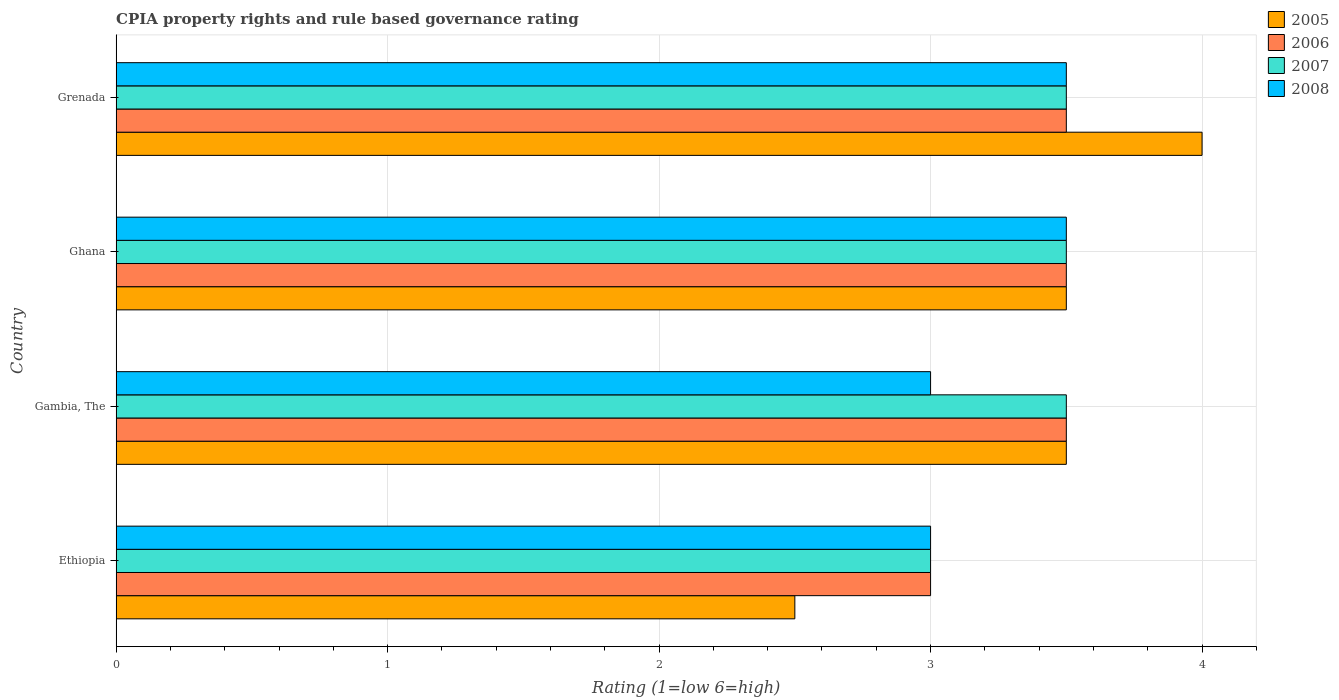How many different coloured bars are there?
Offer a very short reply. 4. How many groups of bars are there?
Provide a short and direct response. 4. Are the number of bars per tick equal to the number of legend labels?
Your answer should be compact. Yes. How many bars are there on the 4th tick from the bottom?
Make the answer very short. 4. What is the label of the 2nd group of bars from the top?
Your answer should be very brief. Ghana. What is the CPIA rating in 2006 in Ethiopia?
Your answer should be compact. 3. Across all countries, what is the maximum CPIA rating in 2005?
Give a very brief answer. 4. In which country was the CPIA rating in 2006 maximum?
Your response must be concise. Gambia, The. In which country was the CPIA rating in 2005 minimum?
Make the answer very short. Ethiopia. What is the average CPIA rating in 2007 per country?
Provide a short and direct response. 3.38. What is the difference between the CPIA rating in 2007 and CPIA rating in 2006 in Ghana?
Ensure brevity in your answer.  0. In how many countries, is the CPIA rating in 2008 greater than 0.4 ?
Provide a succinct answer. 4. Is the CPIA rating in 2008 in Gambia, The less than that in Ghana?
Keep it short and to the point. Yes. Is the difference between the CPIA rating in 2007 in Ethiopia and Ghana greater than the difference between the CPIA rating in 2006 in Ethiopia and Ghana?
Provide a short and direct response. No. What is the difference between the highest and the lowest CPIA rating in 2006?
Make the answer very short. 0.5. Is the sum of the CPIA rating in 2007 in Ghana and Grenada greater than the maximum CPIA rating in 2008 across all countries?
Keep it short and to the point. Yes. What does the 1st bar from the top in Ethiopia represents?
Your response must be concise. 2008. How many bars are there?
Offer a very short reply. 16. Are all the bars in the graph horizontal?
Your response must be concise. Yes. How many countries are there in the graph?
Ensure brevity in your answer.  4. Where does the legend appear in the graph?
Your response must be concise. Top right. How are the legend labels stacked?
Make the answer very short. Vertical. What is the title of the graph?
Keep it short and to the point. CPIA property rights and rule based governance rating. What is the Rating (1=low 6=high) in 2006 in Ethiopia?
Provide a short and direct response. 3. What is the Rating (1=low 6=high) of 2005 in Gambia, The?
Make the answer very short. 3.5. What is the Rating (1=low 6=high) in 2006 in Gambia, The?
Keep it short and to the point. 3.5. What is the Rating (1=low 6=high) in 2007 in Gambia, The?
Give a very brief answer. 3.5. What is the Rating (1=low 6=high) in 2005 in Ghana?
Your response must be concise. 3.5. What is the Rating (1=low 6=high) of 2007 in Ghana?
Provide a short and direct response. 3.5. What is the Rating (1=low 6=high) in 2005 in Grenada?
Offer a terse response. 4. What is the Rating (1=low 6=high) in 2006 in Grenada?
Make the answer very short. 3.5. What is the Rating (1=low 6=high) in 2007 in Grenada?
Offer a very short reply. 3.5. What is the Rating (1=low 6=high) in 2008 in Grenada?
Provide a succinct answer. 3.5. Across all countries, what is the maximum Rating (1=low 6=high) in 2007?
Ensure brevity in your answer.  3.5. Across all countries, what is the minimum Rating (1=low 6=high) of 2005?
Your response must be concise. 2.5. Across all countries, what is the minimum Rating (1=low 6=high) in 2006?
Keep it short and to the point. 3. Across all countries, what is the minimum Rating (1=low 6=high) of 2007?
Ensure brevity in your answer.  3. What is the total Rating (1=low 6=high) in 2005 in the graph?
Make the answer very short. 13.5. What is the total Rating (1=low 6=high) of 2006 in the graph?
Your answer should be very brief. 13.5. What is the total Rating (1=low 6=high) in 2008 in the graph?
Offer a very short reply. 13. What is the difference between the Rating (1=low 6=high) of 2006 in Ethiopia and that in Ghana?
Your answer should be very brief. -0.5. What is the difference between the Rating (1=low 6=high) of 2005 in Ethiopia and that in Grenada?
Give a very brief answer. -1.5. What is the difference between the Rating (1=low 6=high) of 2006 in Ethiopia and that in Grenada?
Provide a succinct answer. -0.5. What is the difference between the Rating (1=low 6=high) in 2007 in Ethiopia and that in Grenada?
Provide a succinct answer. -0.5. What is the difference between the Rating (1=low 6=high) in 2008 in Ethiopia and that in Grenada?
Ensure brevity in your answer.  -0.5. What is the difference between the Rating (1=low 6=high) of 2005 in Gambia, The and that in Ghana?
Provide a short and direct response. 0. What is the difference between the Rating (1=low 6=high) in 2008 in Gambia, The and that in Ghana?
Your response must be concise. -0.5. What is the difference between the Rating (1=low 6=high) in 2006 in Gambia, The and that in Grenada?
Give a very brief answer. 0. What is the difference between the Rating (1=low 6=high) in 2008 in Gambia, The and that in Grenada?
Your answer should be compact. -0.5. What is the difference between the Rating (1=low 6=high) in 2007 in Ghana and that in Grenada?
Provide a succinct answer. 0. What is the difference between the Rating (1=low 6=high) of 2005 in Ethiopia and the Rating (1=low 6=high) of 2008 in Gambia, The?
Keep it short and to the point. -0.5. What is the difference between the Rating (1=low 6=high) in 2006 in Ethiopia and the Rating (1=low 6=high) in 2007 in Gambia, The?
Make the answer very short. -0.5. What is the difference between the Rating (1=low 6=high) in 2006 in Ethiopia and the Rating (1=low 6=high) in 2008 in Gambia, The?
Your response must be concise. 0. What is the difference between the Rating (1=low 6=high) of 2007 in Ethiopia and the Rating (1=low 6=high) of 2008 in Gambia, The?
Keep it short and to the point. 0. What is the difference between the Rating (1=low 6=high) in 2005 in Ethiopia and the Rating (1=low 6=high) in 2007 in Ghana?
Provide a succinct answer. -1. What is the difference between the Rating (1=low 6=high) of 2006 in Ethiopia and the Rating (1=low 6=high) of 2007 in Ghana?
Provide a short and direct response. -0.5. What is the difference between the Rating (1=low 6=high) of 2006 in Ethiopia and the Rating (1=low 6=high) of 2008 in Ghana?
Your response must be concise. -0.5. What is the difference between the Rating (1=low 6=high) of 2005 in Ethiopia and the Rating (1=low 6=high) of 2006 in Grenada?
Offer a very short reply. -1. What is the difference between the Rating (1=low 6=high) in 2006 in Ethiopia and the Rating (1=low 6=high) in 2008 in Grenada?
Give a very brief answer. -0.5. What is the difference between the Rating (1=low 6=high) in 2007 in Ethiopia and the Rating (1=low 6=high) in 2008 in Grenada?
Your response must be concise. -0.5. What is the difference between the Rating (1=low 6=high) of 2005 in Gambia, The and the Rating (1=low 6=high) of 2008 in Ghana?
Your response must be concise. 0. What is the difference between the Rating (1=low 6=high) of 2006 in Gambia, The and the Rating (1=low 6=high) of 2007 in Ghana?
Make the answer very short. 0. What is the difference between the Rating (1=low 6=high) of 2007 in Gambia, The and the Rating (1=low 6=high) of 2008 in Ghana?
Give a very brief answer. 0. What is the difference between the Rating (1=low 6=high) of 2005 in Gambia, The and the Rating (1=low 6=high) of 2006 in Grenada?
Provide a short and direct response. 0. What is the difference between the Rating (1=low 6=high) in 2005 in Gambia, The and the Rating (1=low 6=high) in 2007 in Grenada?
Your answer should be compact. 0. What is the difference between the Rating (1=low 6=high) in 2006 in Gambia, The and the Rating (1=low 6=high) in 2008 in Grenada?
Your answer should be compact. 0. What is the difference between the Rating (1=low 6=high) in 2007 in Gambia, The and the Rating (1=low 6=high) in 2008 in Grenada?
Keep it short and to the point. 0. What is the difference between the Rating (1=low 6=high) in 2005 in Ghana and the Rating (1=low 6=high) in 2007 in Grenada?
Your answer should be very brief. 0. What is the difference between the Rating (1=low 6=high) in 2005 in Ghana and the Rating (1=low 6=high) in 2008 in Grenada?
Give a very brief answer. 0. What is the difference between the Rating (1=low 6=high) of 2006 in Ghana and the Rating (1=low 6=high) of 2007 in Grenada?
Keep it short and to the point. 0. What is the average Rating (1=low 6=high) of 2005 per country?
Keep it short and to the point. 3.38. What is the average Rating (1=low 6=high) in 2006 per country?
Offer a very short reply. 3.38. What is the average Rating (1=low 6=high) of 2007 per country?
Your response must be concise. 3.38. What is the average Rating (1=low 6=high) of 2008 per country?
Make the answer very short. 3.25. What is the difference between the Rating (1=low 6=high) in 2006 and Rating (1=low 6=high) in 2008 in Ethiopia?
Offer a very short reply. 0. What is the difference between the Rating (1=low 6=high) in 2007 and Rating (1=low 6=high) in 2008 in Ethiopia?
Provide a short and direct response. 0. What is the difference between the Rating (1=low 6=high) in 2005 and Rating (1=low 6=high) in 2006 in Gambia, The?
Offer a terse response. 0. What is the difference between the Rating (1=low 6=high) in 2005 and Rating (1=low 6=high) in 2008 in Gambia, The?
Provide a short and direct response. 0.5. What is the difference between the Rating (1=low 6=high) of 2006 and Rating (1=low 6=high) of 2008 in Gambia, The?
Offer a terse response. 0.5. What is the difference between the Rating (1=low 6=high) of 2005 and Rating (1=low 6=high) of 2007 in Ghana?
Your answer should be very brief. 0. What is the difference between the Rating (1=low 6=high) of 2005 and Rating (1=low 6=high) of 2008 in Ghana?
Make the answer very short. 0. What is the difference between the Rating (1=low 6=high) in 2007 and Rating (1=low 6=high) in 2008 in Ghana?
Your answer should be very brief. 0. What is the difference between the Rating (1=low 6=high) in 2005 and Rating (1=low 6=high) in 2006 in Grenada?
Offer a terse response. 0.5. What is the difference between the Rating (1=low 6=high) in 2006 and Rating (1=low 6=high) in 2008 in Grenada?
Keep it short and to the point. 0. What is the ratio of the Rating (1=low 6=high) in 2007 in Ethiopia to that in Gambia, The?
Your response must be concise. 0.86. What is the ratio of the Rating (1=low 6=high) of 2008 in Ethiopia to that in Gambia, The?
Offer a very short reply. 1. What is the ratio of the Rating (1=low 6=high) of 2006 in Ethiopia to that in Ghana?
Provide a succinct answer. 0.86. What is the ratio of the Rating (1=low 6=high) in 2005 in Ethiopia to that in Grenada?
Offer a terse response. 0.62. What is the ratio of the Rating (1=low 6=high) of 2006 in Ethiopia to that in Grenada?
Your answer should be very brief. 0.86. What is the ratio of the Rating (1=low 6=high) of 2006 in Gambia, The to that in Ghana?
Ensure brevity in your answer.  1. What is the ratio of the Rating (1=low 6=high) of 2007 in Gambia, The to that in Ghana?
Your answer should be very brief. 1. What is the ratio of the Rating (1=low 6=high) of 2005 in Gambia, The to that in Grenada?
Your answer should be very brief. 0.88. What is the ratio of the Rating (1=low 6=high) of 2006 in Gambia, The to that in Grenada?
Make the answer very short. 1. What is the ratio of the Rating (1=low 6=high) in 2008 in Gambia, The to that in Grenada?
Ensure brevity in your answer.  0.86. What is the ratio of the Rating (1=low 6=high) in 2006 in Ghana to that in Grenada?
Ensure brevity in your answer.  1. What is the ratio of the Rating (1=low 6=high) in 2008 in Ghana to that in Grenada?
Offer a very short reply. 1. What is the difference between the highest and the second highest Rating (1=low 6=high) in 2005?
Your answer should be compact. 0.5. What is the difference between the highest and the second highest Rating (1=low 6=high) of 2008?
Offer a very short reply. 0. What is the difference between the highest and the lowest Rating (1=low 6=high) in 2005?
Provide a short and direct response. 1.5. What is the difference between the highest and the lowest Rating (1=low 6=high) of 2006?
Keep it short and to the point. 0.5. What is the difference between the highest and the lowest Rating (1=low 6=high) of 2007?
Give a very brief answer. 0.5. What is the difference between the highest and the lowest Rating (1=low 6=high) in 2008?
Keep it short and to the point. 0.5. 